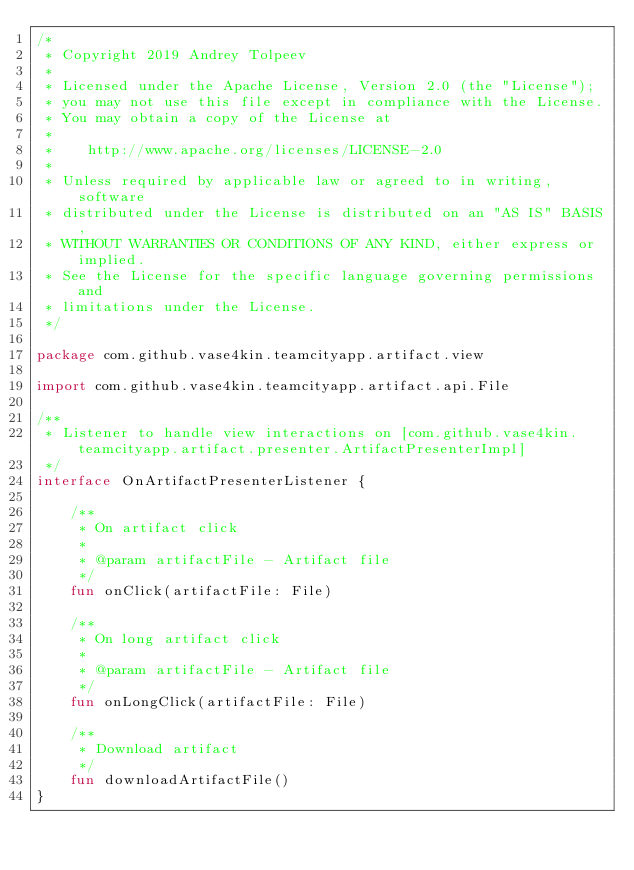<code> <loc_0><loc_0><loc_500><loc_500><_Kotlin_>/*
 * Copyright 2019 Andrey Tolpeev
 *
 * Licensed under the Apache License, Version 2.0 (the "License");
 * you may not use this file except in compliance with the License.
 * You may obtain a copy of the License at
 *
 *    http://www.apache.org/licenses/LICENSE-2.0
 *
 * Unless required by applicable law or agreed to in writing, software
 * distributed under the License is distributed on an "AS IS" BASIS,
 * WITHOUT WARRANTIES OR CONDITIONS OF ANY KIND, either express or implied.
 * See the License for the specific language governing permissions and
 * limitations under the License.
 */

package com.github.vase4kin.teamcityapp.artifact.view

import com.github.vase4kin.teamcityapp.artifact.api.File

/**
 * Listener to handle view interactions on [com.github.vase4kin.teamcityapp.artifact.presenter.ArtifactPresenterImpl]
 */
interface OnArtifactPresenterListener {

    /**
     * On artifact click
     *
     * @param artifactFile - Artifact file
     */
    fun onClick(artifactFile: File)

    /**
     * On long artifact click
     *
     * @param artifactFile - Artifact file
     */
    fun onLongClick(artifactFile: File)

    /**
     * Download artifact
     */
    fun downloadArtifactFile()
}
</code> 